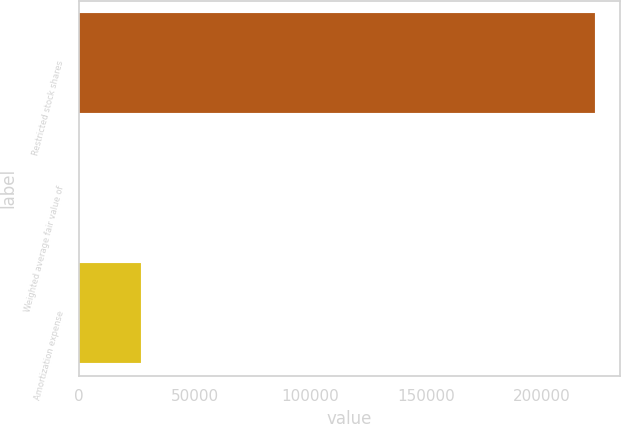<chart> <loc_0><loc_0><loc_500><loc_500><bar_chart><fcel>Restricted stock shares<fcel>Weighted average fair value of<fcel>Amortization expense<nl><fcel>222725<fcel>120.55<fcel>26779<nl></chart> 